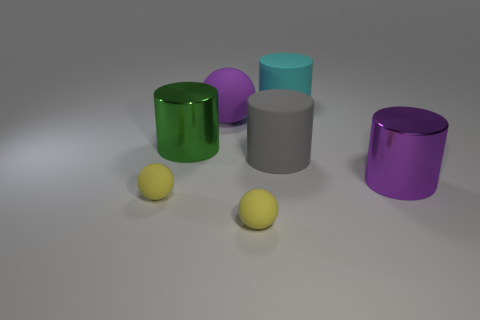Add 2 big green cylinders. How many objects exist? 9 Subtract all brown cylinders. Subtract all red blocks. How many cylinders are left? 4 Subtract all cylinders. How many objects are left? 3 Add 6 big matte cylinders. How many big matte cylinders are left? 8 Add 6 cyan matte things. How many cyan matte things exist? 7 Subtract 0 yellow cylinders. How many objects are left? 7 Subtract all big cyan metal things. Subtract all big purple spheres. How many objects are left? 6 